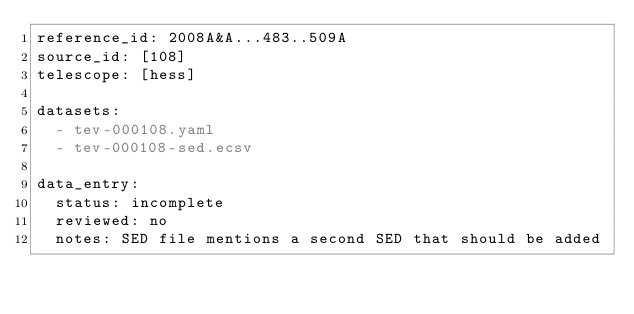<code> <loc_0><loc_0><loc_500><loc_500><_YAML_>reference_id: 2008A&A...483..509A
source_id: [108]
telescope: [hess]

datasets:
  - tev-000108.yaml
  - tev-000108-sed.ecsv

data_entry:
  status: incomplete
  reviewed: no
  notes: SED file mentions a second SED that should be added
</code> 